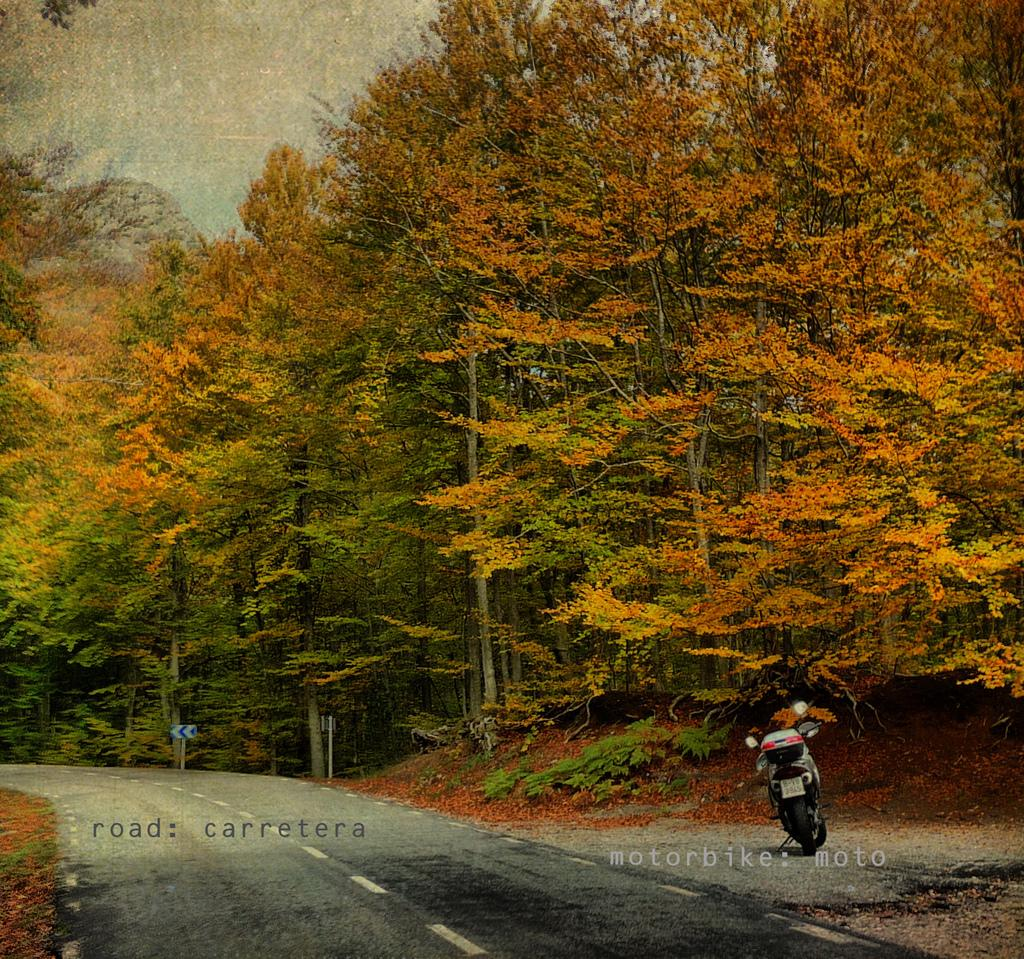What type of natural elements can be seen in the image? There are trees in the image. What type of man-made structure is visible in the image? There is a road with white lines in the image. What type of information might be conveyed by the sign board in the image? The sign board in the image might convey information about directions, warnings, or other notices. What type of work is being done on the trees in the image? There is no indication of any work being done on the trees in the image; they appear to be standing naturally. 